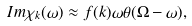Convert formula to latex. <formula><loc_0><loc_0><loc_500><loc_500>I m \chi _ { k } ( \omega ) \approx f ( k ) \omega \theta ( \Omega - \omega ) ,</formula> 